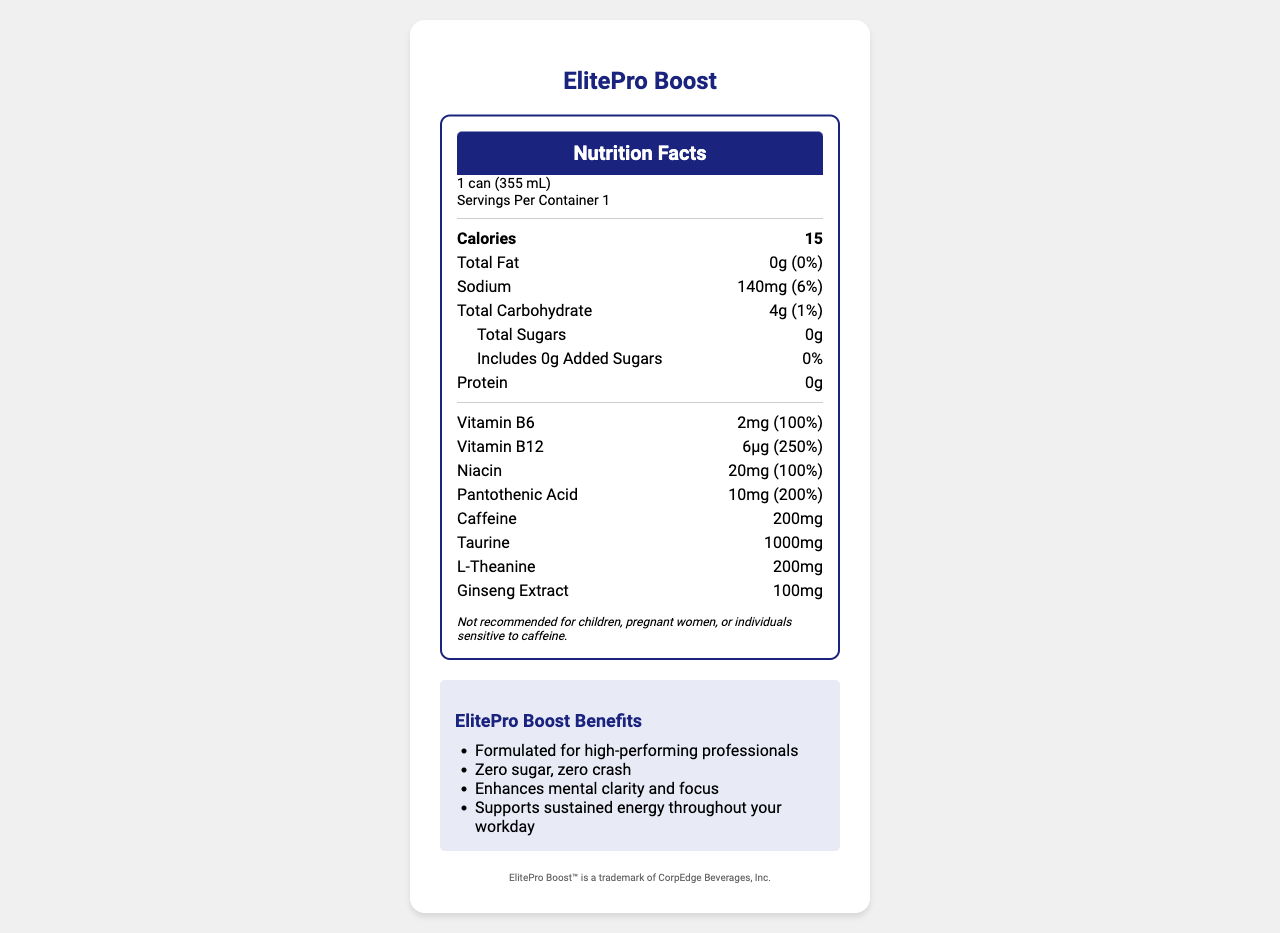what is the product name? The product name is clearly displayed at the top of the document in large text.
Answer: ElitePro Boost How many calories are in one can of ElitePro Boost? The document states that each can contains 15 calories.
Answer: 15 How much sodium is in a serving of ElitePro Boost? The document lists the sodium content as 140mg.
Answer: 140mg What is the percentage Daily Value of Vitamin B12 in ElitePro Boost? The label indicates the Vitamin B12 content provides 250% of the Daily Value.
Answer: 250% What are the active ingredients in ElitePro Boost aside from vitamins? The document lists these ingredients separately from the vitamins and minerals.
Answer: Caffeine, Taurine, L-Theanine, Ginseng Extract Which of the following is not an ingredient in ElitePro Boost? A. Citric Acid B. Aspartame C. Sucralose The document lists Citric Acid and Sucralose as ingredients but not Aspartame.
Answer: B. Aspartame How much protein does ElitePro Boost contain? The document clearly states that the protein content is 0g.
Answer: 0g Does ElitePro Boost contain any added sugars? The document states that the amount of added sugars is 0g and the Daily Value is 0%.
Answer: No What is the primary purpose of ElitePro Boost according to its marketing claims? The marketing section claims it enhances mental clarity and focus and supports sustained energy throughout the workday.
Answer: Enhances mental clarity and focus, supports sustained energy What allergen information is provided for ElitePro Boost? A. Contains milk B. Produced in a facility that processes soy and milk C. Contains soy The allergen information provided states that the product is manufactured in a facility that processes soy and milk products.
Answer: B. Produced in a facility that processes soy and milk Is ElitePro Boost recommended for children? The disclaimer mentions that it is not recommended for children, pregnant women, or individuals sensitive to caffeine.
Answer: No Summarize the nutrition facts and purpose of ElitePro Boost. This summary combines the key nutrition facts with the marketing claims and purpose outlined in the document.
Answer: ElitePro Boost is a low-calorie energy drink designed for high-performing professionals. It contains 15 calories per can, with no fat, sugars, or protein. Key ingredients include caffeine (200mg), taurine (1000mg), L-theanine (200mg), and ginseng extract (100mg). It provides high percentages of several B vitamins, including B6, B12, Niacin, and Pantothenic Acid. Marketed benefits include enhanced mental clarity and sustained energy. How much niacin is in one serving of ElitePro Boost? The nutrient section specifies the amount of Niacin as 20mg.
Answer: 20mg Can the effectiveness of ElitePro Boost's ingredients in enhancing mental clarity be determined from this document? The document lists the ingredients and their amounts but does not provide evidence or studies proving their effectiveness in enhancing mental clarity.
Answer: Not enough information Describe the disclaimer provided on the document in your own words. The disclaimer advises that the product should not be consumed by certain groups of people, specifically children, pregnant women, and those who are sensitive to caffeine, due to potential adverse effects.
Answer: Not recommended for children, pregnant women, or individuals sensitive to caffeine. 